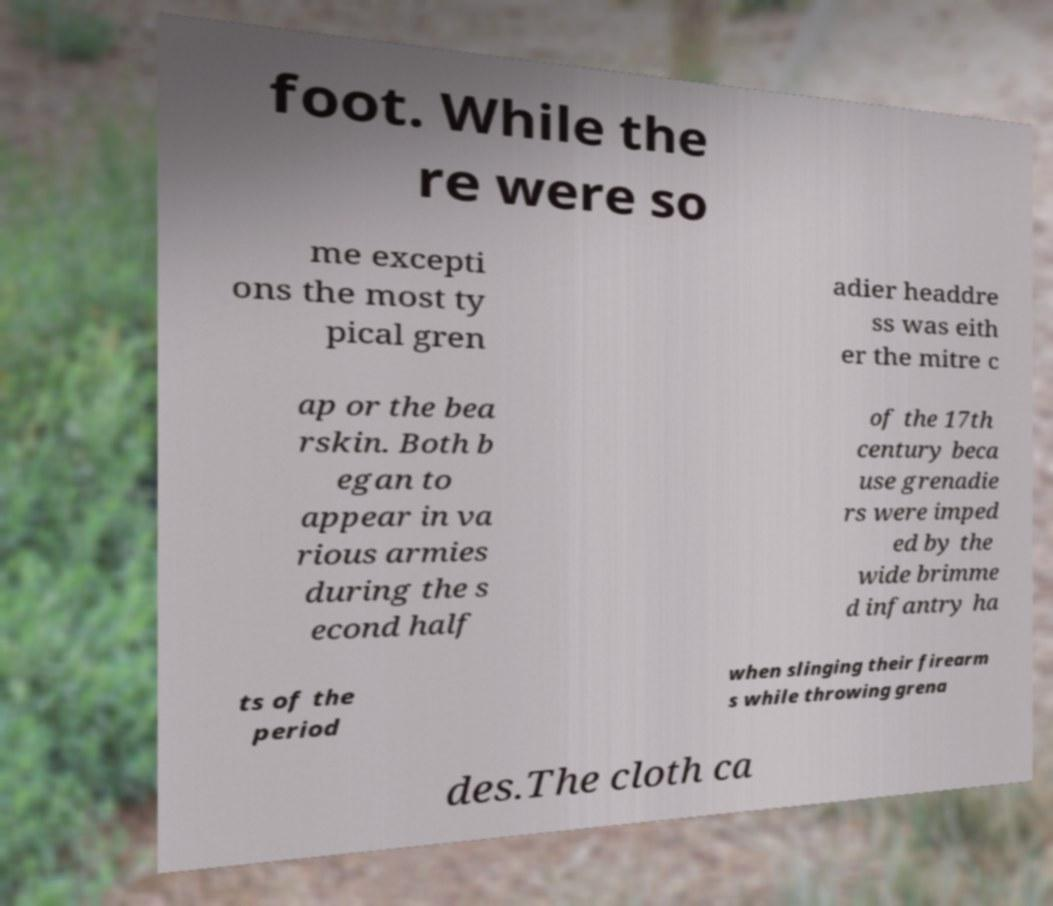Can you accurately transcribe the text from the provided image for me? foot. While the re were so me excepti ons the most ty pical gren adier headdre ss was eith er the mitre c ap or the bea rskin. Both b egan to appear in va rious armies during the s econd half of the 17th century beca use grenadie rs were imped ed by the wide brimme d infantry ha ts of the period when slinging their firearm s while throwing grena des.The cloth ca 